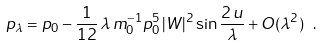Convert formula to latex. <formula><loc_0><loc_0><loc_500><loc_500>p _ { \lambda } = p _ { 0 } - \frac { 1 } { 1 2 } \, \lambda \, m _ { 0 } ^ { - 1 } p _ { 0 } ^ { 5 } \, | W | ^ { 2 } \sin \frac { 2 \, u } { \lambda } + O ( \lambda ^ { 2 } ) \ .</formula> 